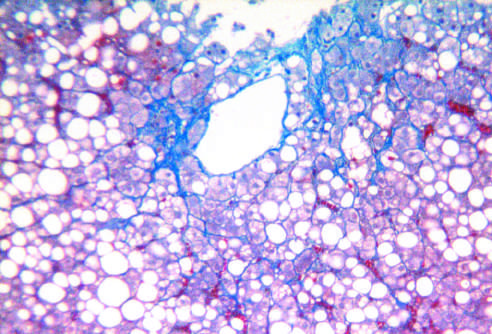s fatty liver disease associated with chronic alcohol use?
Answer the question using a single word or phrase. Yes 